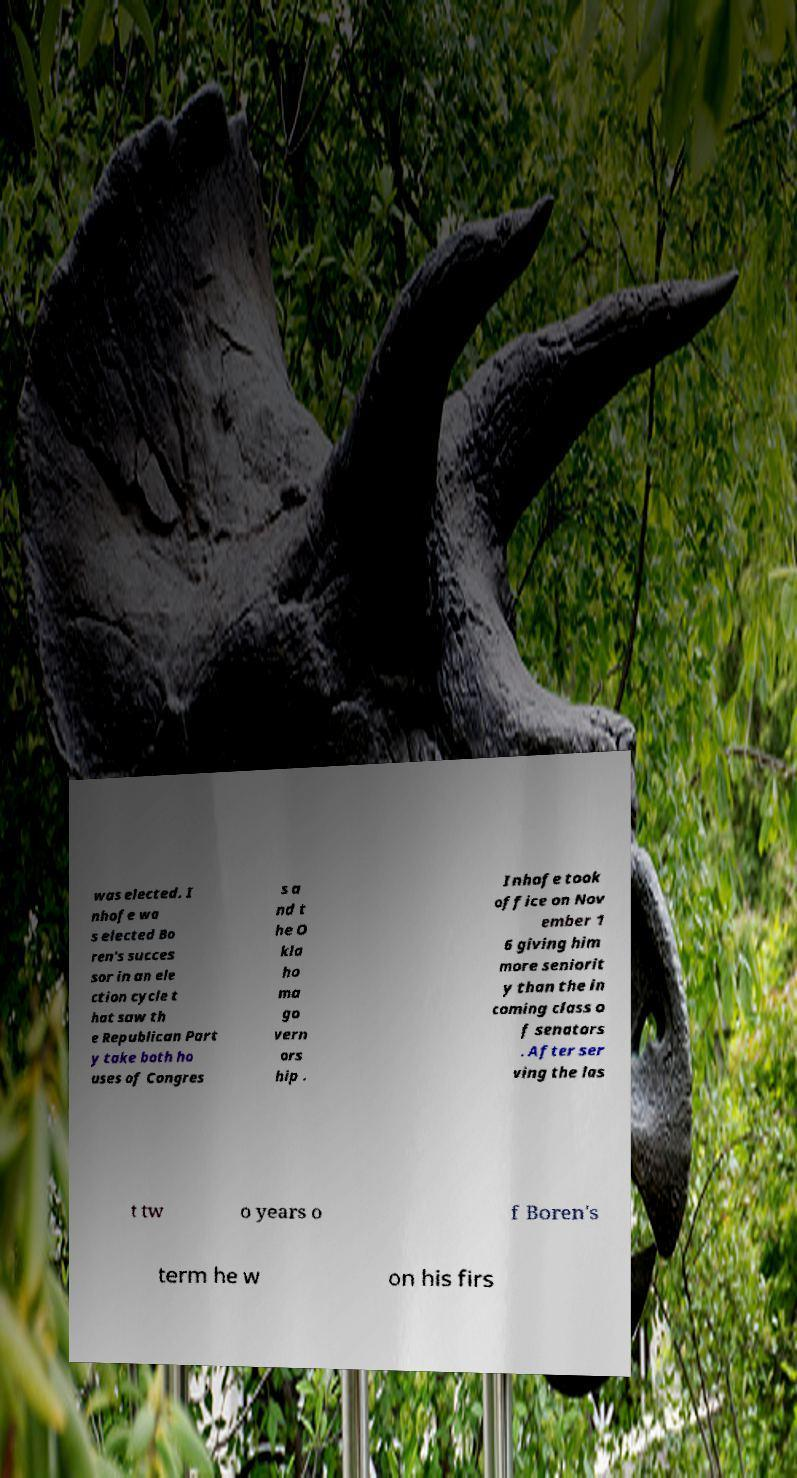There's text embedded in this image that I need extracted. Can you transcribe it verbatim? was elected. I nhofe wa s elected Bo ren's succes sor in an ele ction cycle t hat saw th e Republican Part y take both ho uses of Congres s a nd t he O kla ho ma go vern ors hip . Inhofe took office on Nov ember 1 6 giving him more seniorit y than the in coming class o f senators . After ser ving the las t tw o years o f Boren's term he w on his firs 